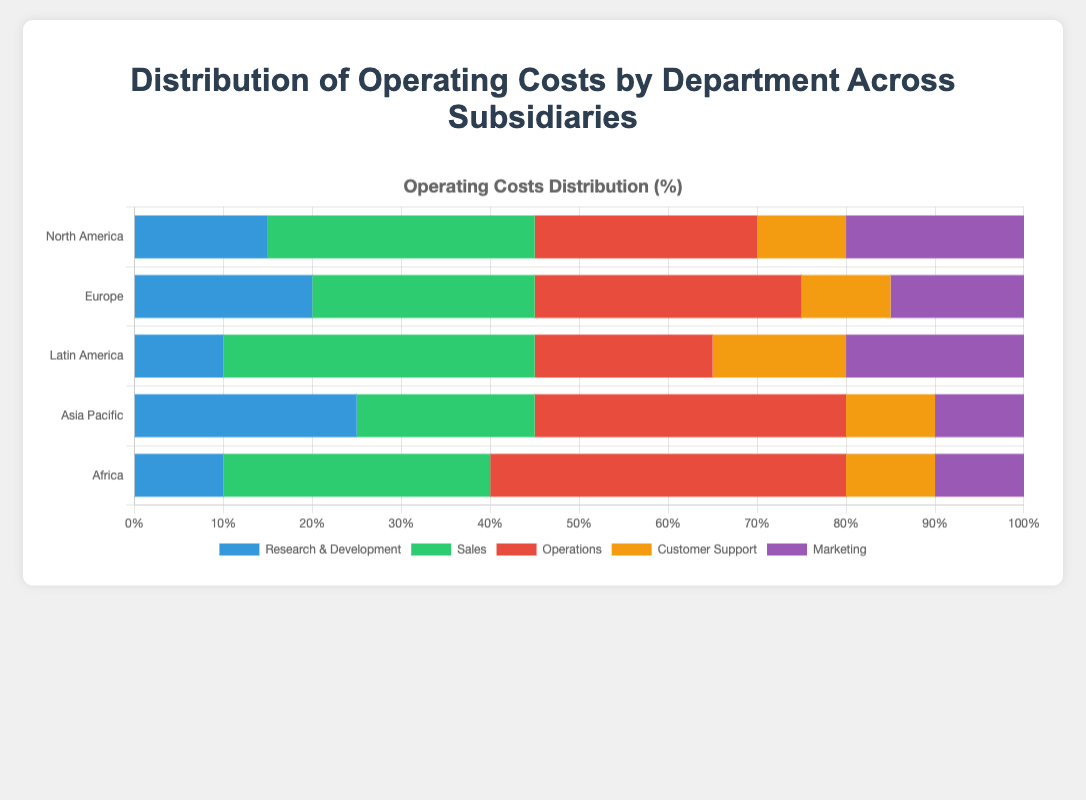Which department has the highest operating cost in North America? The bar for the Sales department in North America has the largest segment in the horizontal stacked bar compared to other departments.
Answer: Sales What is the total percentage of operating costs for Research & Development and Marketing in Europe? The percentage for Research & Development is 20% and for Marketing is 15%. Adding them gives us 20 + 15 = 35%.
Answer: 35% Which subsidiary has the lowest operating costs allocated to Customer Support? By observing the lengths of the bars for Customer Support across all subsidiaries, Latin America, Asia Pacific, and Africa each have a 10% allocation. Since they all have the same percentage, there's no single lowest, but they share it equally.
Answer: Latin America, Asia Pacific, Africa Compare the operating costs of Operations in Asia Pacific and Latin America. Which one is higher and by how much? The percentage for Operations in Asia Pacific is 35%, while in Latin America it is 20%. The difference is 35 - 20 = 15%.
Answer: Asia Pacific, 15% Which department has the smallest variance in operating costs across all subsidiaries? Looking at the bar segments for each department, Customer Support is consistently at 10% across all subsidiaries, indicating the smallest variance.
Answer: Customer Support What is the combined percentage of Sales and Operations costs in Africa? The percentage for Sales is 30% and for Operations is 40%. Adding them gives us 30 + 40 = 70%.
Answer: 70% How does the Marketing cost distribution in Latin America compare to that in Asia Pacific in terms of percentage? The percentage for Marketing in Latin America is 20%, while in Asia Pacific it is 10%. The Marketing cost in Latin America is 10% higher than in Asia Pacific.
Answer: 10% higher in Latin America Which subsidiary allocates the largest percentage of its operating costs to Research & Development? By comparing the bar segments for Research & Development, Asia Pacific allocates 25%, which is the highest among the subsidiaries.
Answer: Asia Pacific What is the average percentage of operating costs for Sales across all subsidiaries? The Sales percentages are 30%, 25%, 35%, 20%, and 30%. Summing these gives 30 + 25 + 35 + 20 + 30 = 140 and the average is 140 / 5 = 28%.
Answer: 28% 